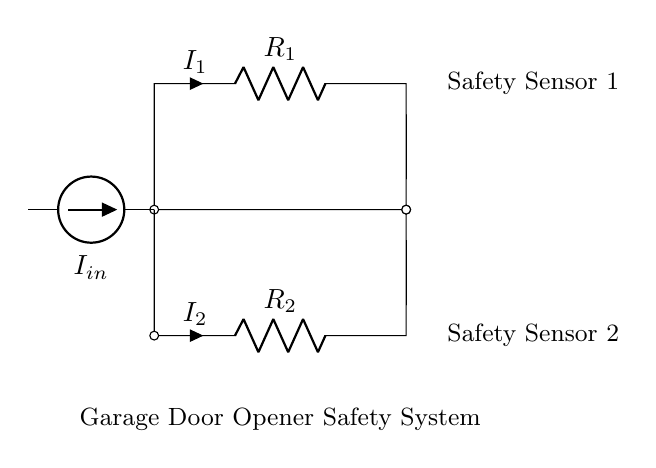What are the resistances in this circuit? The circuit diagram shows two resistors labeled R1 and R2. These resistances are the components of the current divider, determining the current through each path.
Answer: R1, R2 What is the purpose of the current source in this circuit? The current source labeled Iin provides a constant input current to the circuit. This current is divided between the two branches (R1 and R2) based on their resistances.
Answer: To supply input current How does the current divide between R1 and R2? In a current divider, the total input current (Iin) divides inversely proportional to the resistance values. The higher the resistance, the lower the current through that resistor. The formula I2 = Iin * (R1 / (R1 + R2)) can be used to find the current through R2.
Answer: Inversely proportional to resistance What is the relationship between I1 and I2? According to the rules of a current divider, the currents I1 and I2 will add up to the total input current Iin. Mathematically, Iin = I1 + I2. This shows that as one current increases, the other decreases if Iin is constant.
Answer: Iin = I1 + I2 What would happen if one safety sensor fails? If one of the resistors (safety sensors) fails, the current through the other sensor would increase significantly, possibly leading to a fault or failure of that sensor. In practice, the circuit might shut down to avoid damage.
Answer: Increased current and potential failure What role do the safety sensors play in this circuit? The safety sensors (R1 and R2) are crucial in the garage door opener system. They help detect obstructions, allowing the door to reverse if necessary. If one sensor detects an obstruction, the circuit reacts to prevent the door from closing.
Answer: Detect obstructions 